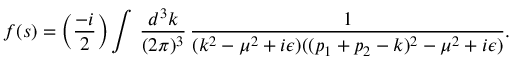Convert formula to latex. <formula><loc_0><loc_0><loc_500><loc_500>f ( s ) = \left ( { \frac { - i } { 2 } } \right ) \int \, { \frac { d ^ { 3 } k } { ( 2 \pi ) ^ { 3 } } } \, { \frac { 1 } { ( k ^ { 2 } - \mu ^ { 2 } + i \epsilon ) ( ( p _ { 1 } + p _ { 2 } - k ) ^ { 2 } - \mu ^ { 2 } + i \epsilon ) } } .</formula> 